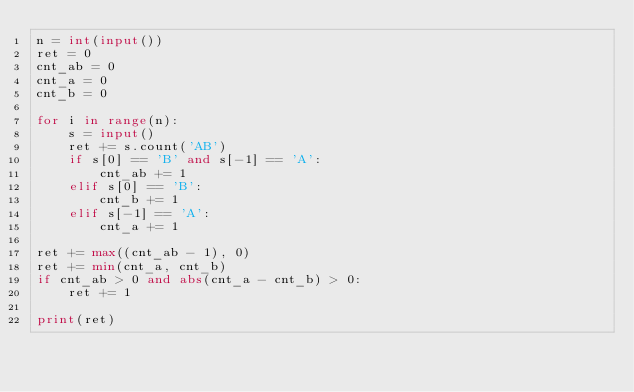Convert code to text. <code><loc_0><loc_0><loc_500><loc_500><_Python_>n = int(input())
ret = 0
cnt_ab = 0
cnt_a = 0
cnt_b = 0

for i in range(n):
    s = input()
    ret += s.count('AB')
    if s[0] == 'B' and s[-1] == 'A':
        cnt_ab += 1
    elif s[0] == 'B':
        cnt_b += 1
    elif s[-1] == 'A':
        cnt_a += 1

ret += max((cnt_ab - 1), 0)
ret += min(cnt_a, cnt_b)
if cnt_ab > 0 and abs(cnt_a - cnt_b) > 0:
    ret += 1

print(ret)
</code> 